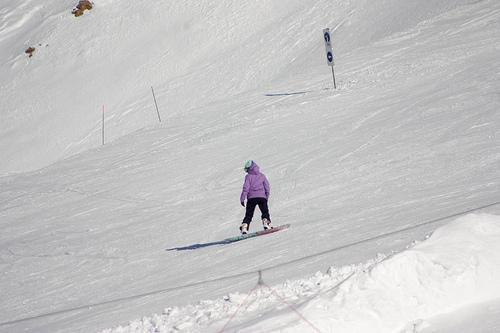How many people are skiing?
Give a very brief answer. 1. 